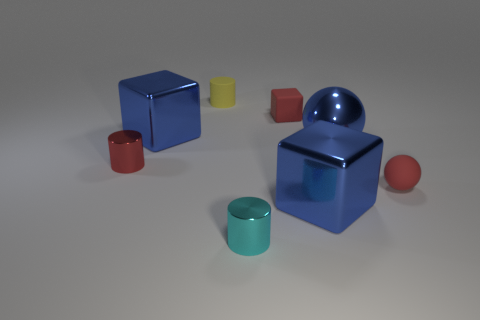Can you tell me about the textures of the objects? Certainly! The objects have two distinct textures. The cubes and the sphere have a shiny, metallic surface that reflects light, giving them a glossy appearance. On the other hand, the cylinders appear to have a matte texture that diffuses the light, providing a contrast to the reflective quality of the metallic objects. 